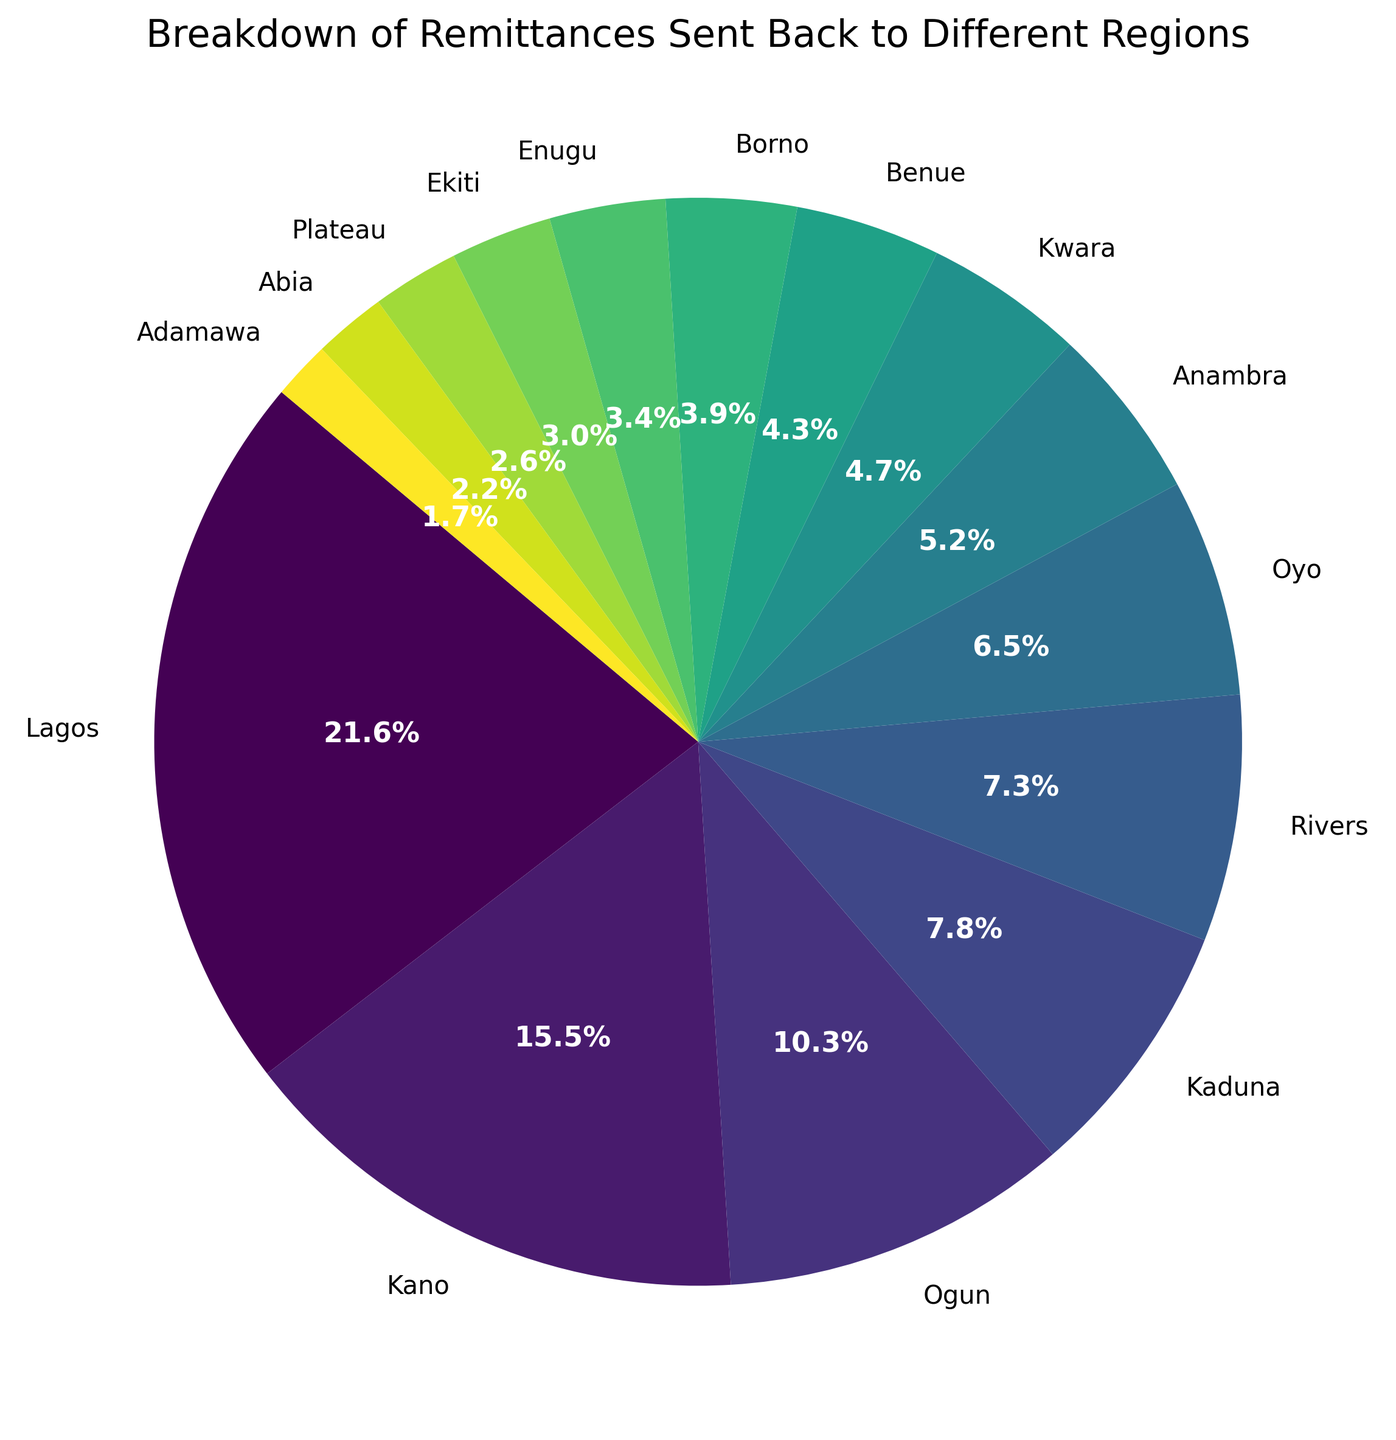Which region receives the highest remittances? The region with the highest remittances is identified by finding the largest segment in the pie chart. The largest segment corresponds to Lagos.
Answer: Lagos What percentage of total remittances is sent to Ogun? To find this, identify the segment labeled "Ogun" and note its percentage annotation on the pie chart.
Answer: 12.0% How much more is sent to Lagos than to Kano? Lagos receives $250,000 and Kano receives $180,000. The difference is found by subtracting Kano's amount from Lagos's amount: $250,000 - $180,000 = $70,000.
Answer: $70,000 Which region receives the smallest remittances, and what percentage does it represent? The smallest segment of the pie chart corresponds to the region with the least remittances. The chart shows this region as Adamawa, and the percentage listed for Adamawa's segment is reviewed.
Answer: Adamawa, 1.1% How does the remittance amount sent to Rivers compare to that sent to Ogun? Rivers receives $85,000 and Ogun receives $120,000. Comparing the two amounts shows that Rivers receives less than Ogun: $85,000 < $120,000.
Answer: Rivers receives less than Ogun What is the combined percentage of remittances for Kwara and Benue? Kwara's segment shows 5.3% and Benue's segment shows 4.8%. Adding these percentages together, we get 5.3% + 4.8% = 10.1%.
Answer: 10.1% Is the remittance to Oyo greater than to Anambra? Oyo receives $75,000 while Anambra receives $60,000. Comparing these figures, Oyo's amount is greater: $75,000 > $60,000.
Answer: Yes What is the median value of remittances sent to the regions? The given amounts are: $250,000, $180,000, $120,000, $90,000, $85,000, $75,000, $60,000, $55,000, $50,000, $45,000, $40,000, $35,000, $30,000, $25,000, $20,000. Sorting these amounts and finding the middle value, the median is $55,000.
Answer: $55,000 What percentage of total remittances is sent to the top three regions combined? The top three regions are Lagos, Kano, and Ogun receiving $250,000, $180,000, and $120,000 respectively. Their combined amount is $250,000 + $180,000 + $120,000 = $550,000. Each segment’s percentage adding gives approximately 46.0% + 33.1% + 12.0% = 91.1%.
Answer: 91.1% 